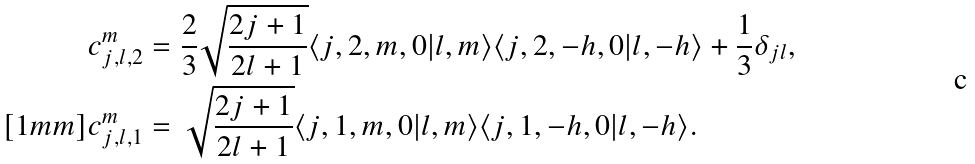<formula> <loc_0><loc_0><loc_500><loc_500>c ^ { m } _ { j , l , 2 } & = \frac { 2 } { 3 } \sqrt { \frac { 2 j + 1 } { 2 l + 1 } } \langle j , 2 , m , 0 | l , m \rangle \langle j , 2 , - h , 0 | l , - h \rangle + \frac { 1 } { 3 } \delta _ { j l } , \\ [ 1 m m ] c ^ { m } _ { j , l , 1 } & = \, \sqrt { \frac { 2 j + 1 } { 2 l + 1 } } \langle j , 1 , m , 0 | l , m \rangle \langle j , 1 , - h , 0 | l , - h \rangle .</formula> 